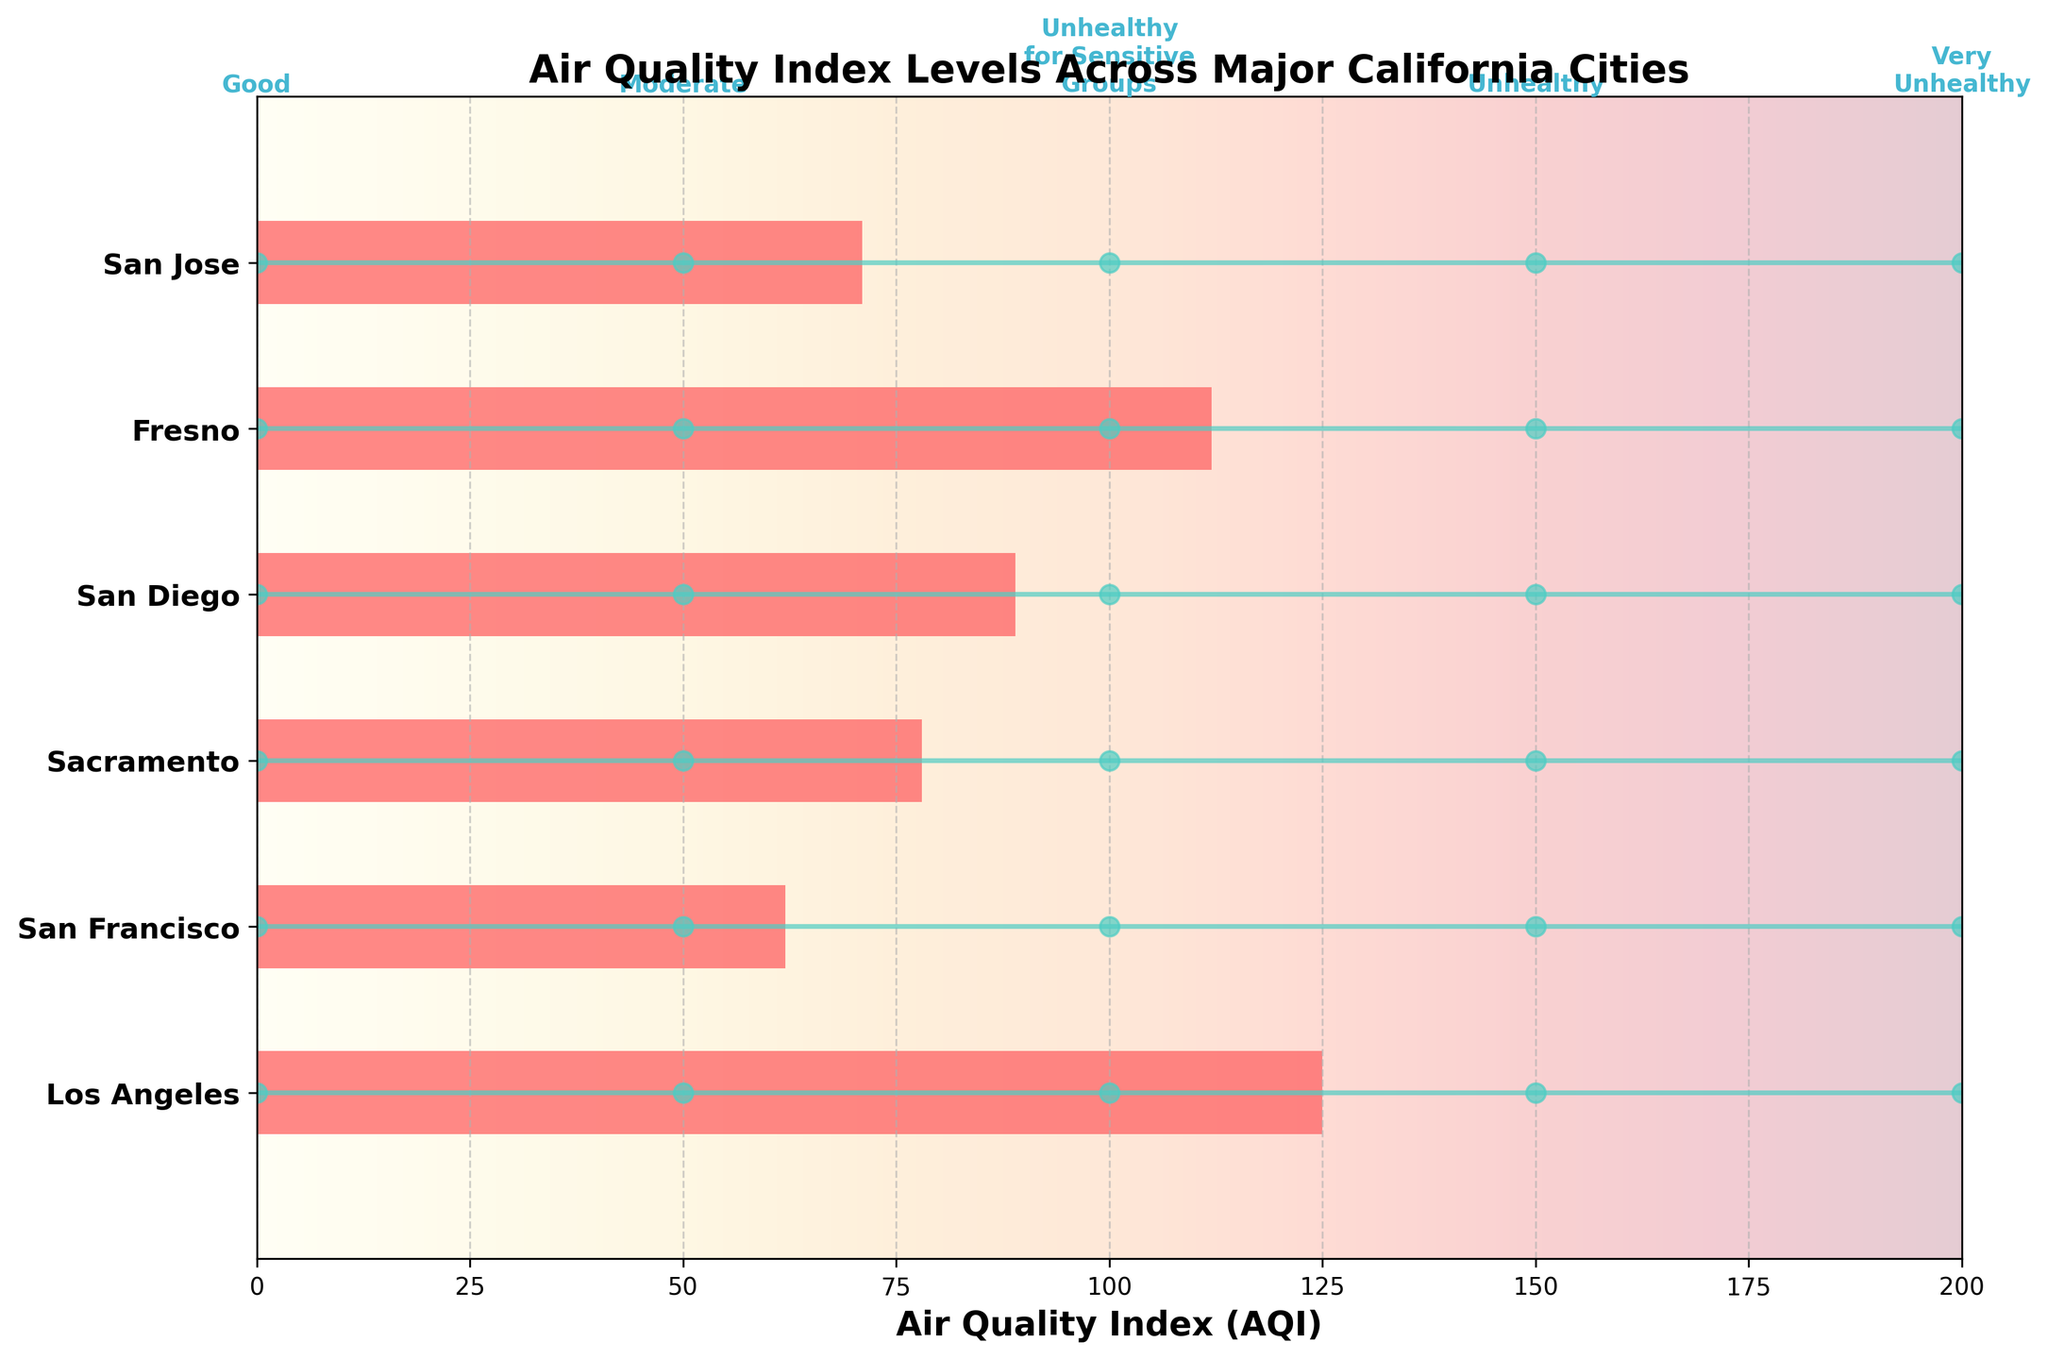What's the title of the figure? The title of the figure is displayed prominently at the top of the chart area.
Answer: Air Quality Index Levels Across Major California Cities What is the AQI value for Los Angeles? Locate the bar representing Los Angeles on the vertical axis and read the AQI value indicated by the end of the bar on the horizontal axis.
Answer: 125 Which city has the lowest AQI value? Compare the lengths of the AQI bars for each city to determine the shortest one on the horizontal axis.
Answer: San Francisco How many cities have an AQI value above 100? Identify and count the cities whose AQI bars extend beyond the 100 mark on the horizontal axis.
Answer: 2 Compare the AQI values of San Diego and San Jose. Which one is higher? Find the AQI bars for San Diego and San Jose, then compare their lengths. The longer bar corresponds to the higher AQI.
Answer: San Diego Are there any cities that fall in the 'Unhealthy' zone based on the EPA standards? Check the endpoint of each city's AQI bar to see if any extend into the 'Unhealthy' zone (beyond 150) on the horizontal axis.
Answer: No Which city is closest to the 'Moderate' level of 50 AQI? Determine the AQI bar whose endpoint is nearest to the 50 mark on the horizontal axis.
Answer: San Francisco Rank the cities from highest to lowest AQI value. Compare the lengths of all AQI bars and order them from longest to shortest.
Answer: Los Angeles, Fresno, San Diego, Sacramento, San Jose, San Francisco How many cities fall within the 'Unhealthy for Sensitive Groups' range (100-150)? Identify and count the cities with AQI bars ending between 100 and 150 on the horizontal axis.
Answer: 2 